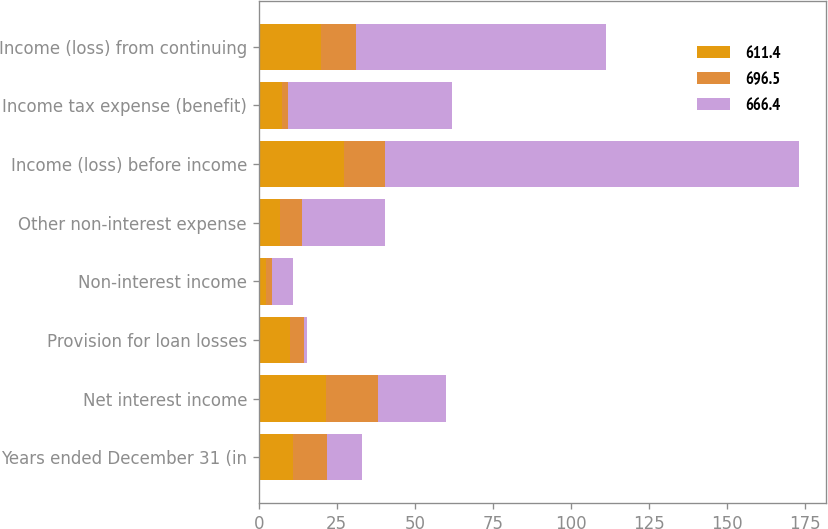Convert chart to OTSL. <chart><loc_0><loc_0><loc_500><loc_500><stacked_bar_chart><ecel><fcel>Years ended December 31 (in<fcel>Net interest income<fcel>Provision for loan losses<fcel>Non-interest income<fcel>Other non-interest expense<fcel>Income (loss) before income<fcel>Income tax expense (benefit)<fcel>Income (loss) from continuing<nl><fcel>611.4<fcel>11<fcel>21.7<fcel>10.1<fcel>2.3<fcel>6.8<fcel>27.3<fcel>7.3<fcel>20<nl><fcel>696.5<fcel>11<fcel>16.6<fcel>4.3<fcel>2<fcel>7.2<fcel>13<fcel>2<fcel>11<nl><fcel>666.4<fcel>11<fcel>21.7<fcel>1.2<fcel>6.8<fcel>26.6<fcel>132.7<fcel>52.5<fcel>80.2<nl></chart> 